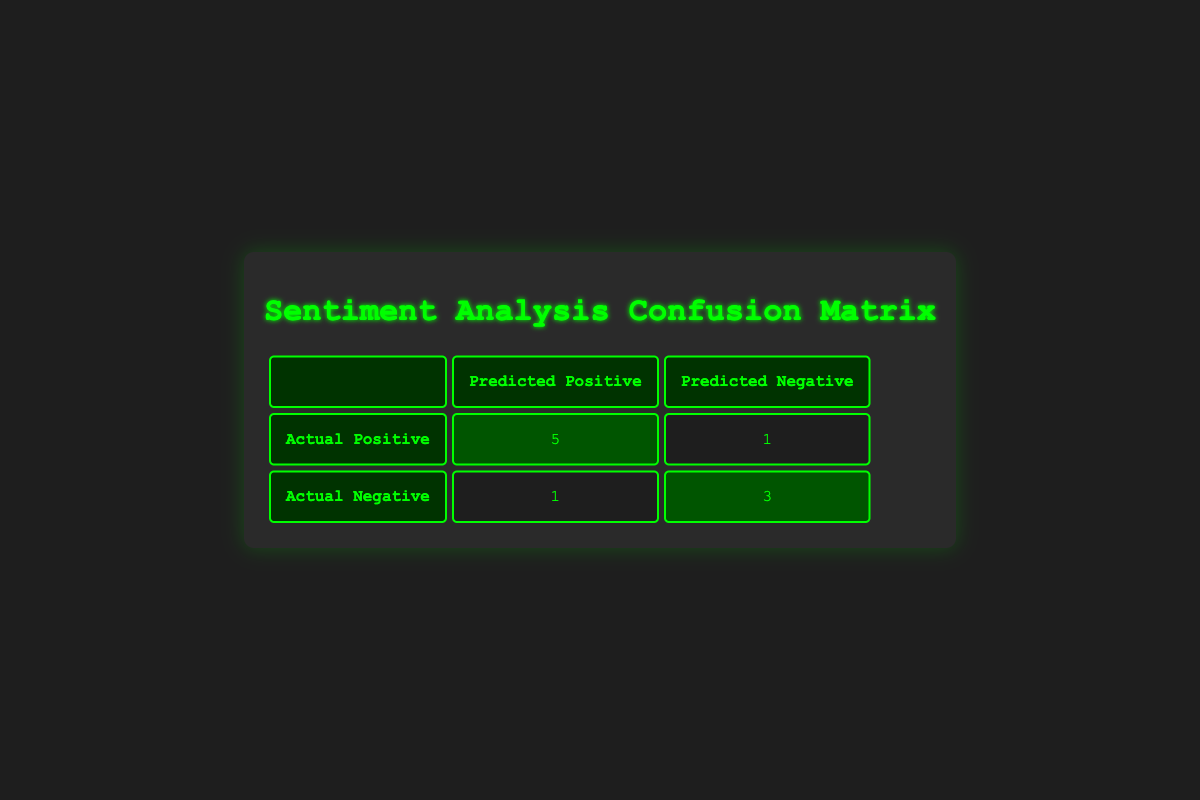What is the total number of actual positive sentiments? In the confusion matrix, we look at the Actual Positive row, which shows that there are 5 true positives and 1 false negative. Therefore, the total number of actual positive sentiments is 5 + 1 = 6.
Answer: 6 How many total reviews were classified as negative? We can determine the total number of reviews classified as negative by summing the false positive (1) and true negative (3) values in the Actual Negative row. This yields a total of 1 + 3 = 4.
Answer: 4 Are there more true positives than true negatives? From the table, true positives are shown as 5 and true negatives as 3. Since 5 is greater than 3, there are more true positives than true negatives.
Answer: Yes What is the total number of sentiments predicted as positive? The predicted positive sentiment includes true positives (5) and false positives (1). Adding these values gives us a total of 5 + 1 = 6 positive predictions.
Answer: 6 How many more actual positive sentiments are there than actual negative sentiments? The actual positives total 6 (5 true positives + 1 false negative), while the actual negatives total 4 (3 true negatives + 1 false positive). Therefore, the difference is 6 - 4 = 2, meaning there are 2 more actual positive sentiments than actual negative sentiments.
Answer: 2 What percentage of the predicted sentiments were positive? The total predicted sentiments are the sum of true positives (5) and false positives (1), which equals 6. The percentage of positive predictions is (5/6) * 100, which results in approximately 83.33%.
Answer: Approximately 83.33% If one more negative review is added to the data and classified correctly, how would that affect the true negatives? The current total of true negatives is 3. Adding a correctly classified negative review would increase true negatives by 1, resulting in 3 + 1 = 4 true negatives.
Answer: 4 What is the overall accuracy of the sentiment predictions? The overall accuracy can be calculated as (true positives + true negatives) / total reviews. There are 8 total reviews (5 true positives + 3 true negatives), so accuracy is (5 + 3) / 10 = 0.8 or 80%.
Answer: 80% 